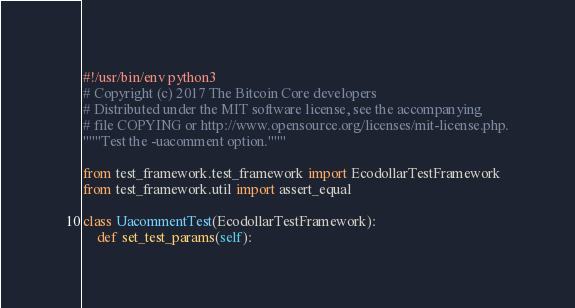Convert code to text. <code><loc_0><loc_0><loc_500><loc_500><_Python_>#!/usr/bin/env python3
# Copyright (c) 2017 The Bitcoin Core developers
# Distributed under the MIT software license, see the accompanying
# file COPYING or http://www.opensource.org/licenses/mit-license.php.
"""Test the -uacomment option."""

from test_framework.test_framework import EcodollarTestFramework
from test_framework.util import assert_equal

class UacommentTest(EcodollarTestFramework):
    def set_test_params(self):</code> 